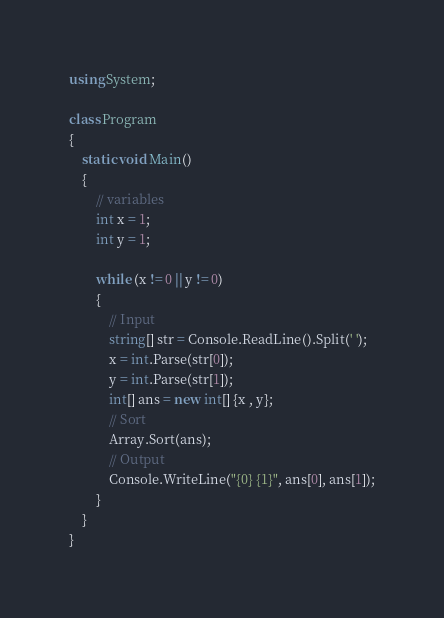<code> <loc_0><loc_0><loc_500><loc_500><_C#_>using System;

class Program
{
    static void Main()
    {
        // variables
        int x = 1;
        int y = 1;

        while (x != 0 || y != 0)
        {
            // Input
            string[] str = Console.ReadLine().Split(' ');
            x = int.Parse(str[0]);
            y = int.Parse(str[1]);
            int[] ans = new int[] {x , y};
            // Sort
            Array.Sort(ans);
            // Output
            Console.WriteLine("{0} {1}", ans[0], ans[1]);
        }
    }
}</code> 